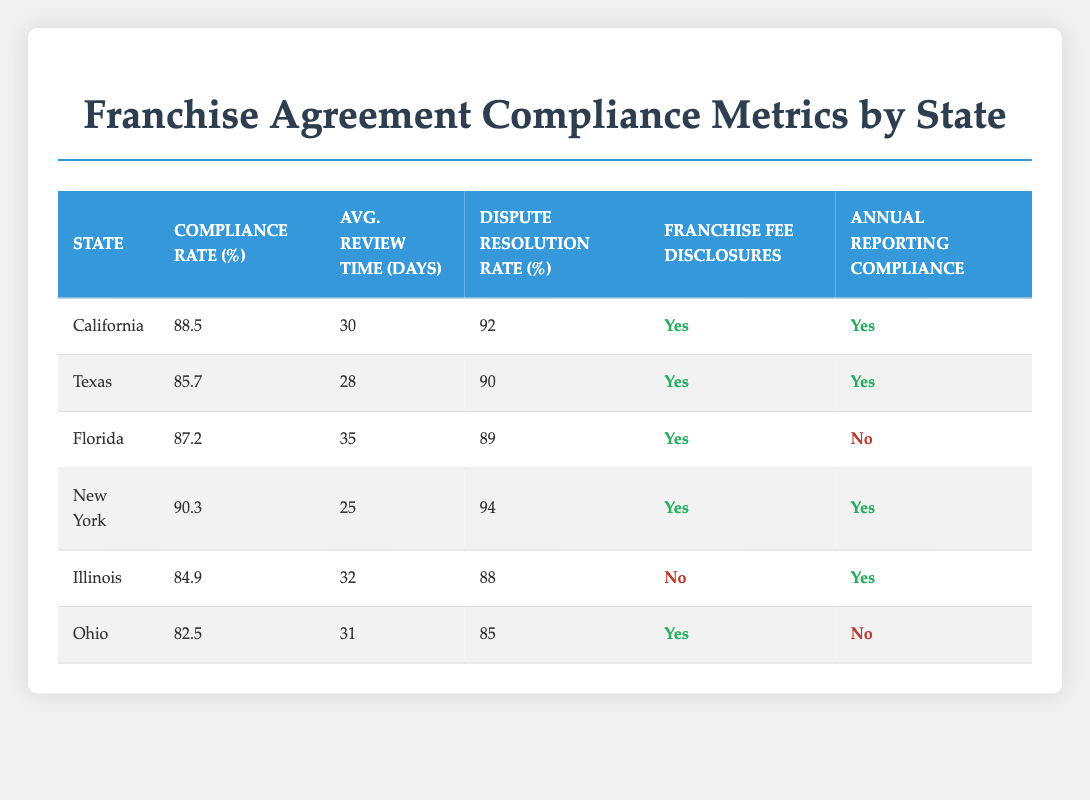What is the compliance rate for Florida? The table indicates that the compliance rate for Florida is explicitly listed in the row corresponding to that state, which shows 87.2%.
Answer: 87.2 Which state has the highest average review time in days? By examining the "Avg. Review Time (Days)" column for each state, we see that Florida has the highest value of 35 days, which is greater than any other state listed.
Answer: Florida Is there annual reporting compliance in Ohio? In the row for Ohio, the "Annual Reporting Compliance" column indicates "No," clearly showing that there is no compliance for annual reporting in that state.
Answer: No What is the average compliance rate for states with franchise fee disclosures? The states with franchise fee disclosures are California, Texas, Florida, New York, and Ohio. Their compliance rates are 88.5, 85.7, 87.2, 90.3, and 82.5 respectively. Summing these values gives 88.5 + 85.7 + 87.2 + 90.3 + 82.5 = 434.2. Dividing 434.2 by 5 (the number of states) provides an average compliance rate of 86.84.
Answer: 86.84 Which state has the lowest dispute resolution rate? Evaluating the "Dispute Resolution Rate (%)" from the table, Ohio has the lowest rate at 85%, which is less than all other states listed.
Answer: Ohio 